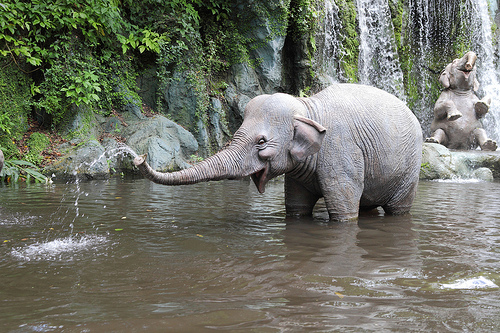Are there any other animals or significant features in the image? Apart from the primary elephant, there is another elephant in the background, partially obscured by the waterfall and vegetation. The surrounding area is lush and green, indicating a rich, biodiverse habitat. 